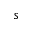Convert formula to latex. <formula><loc_0><loc_0><loc_500><loc_500>s</formula> 